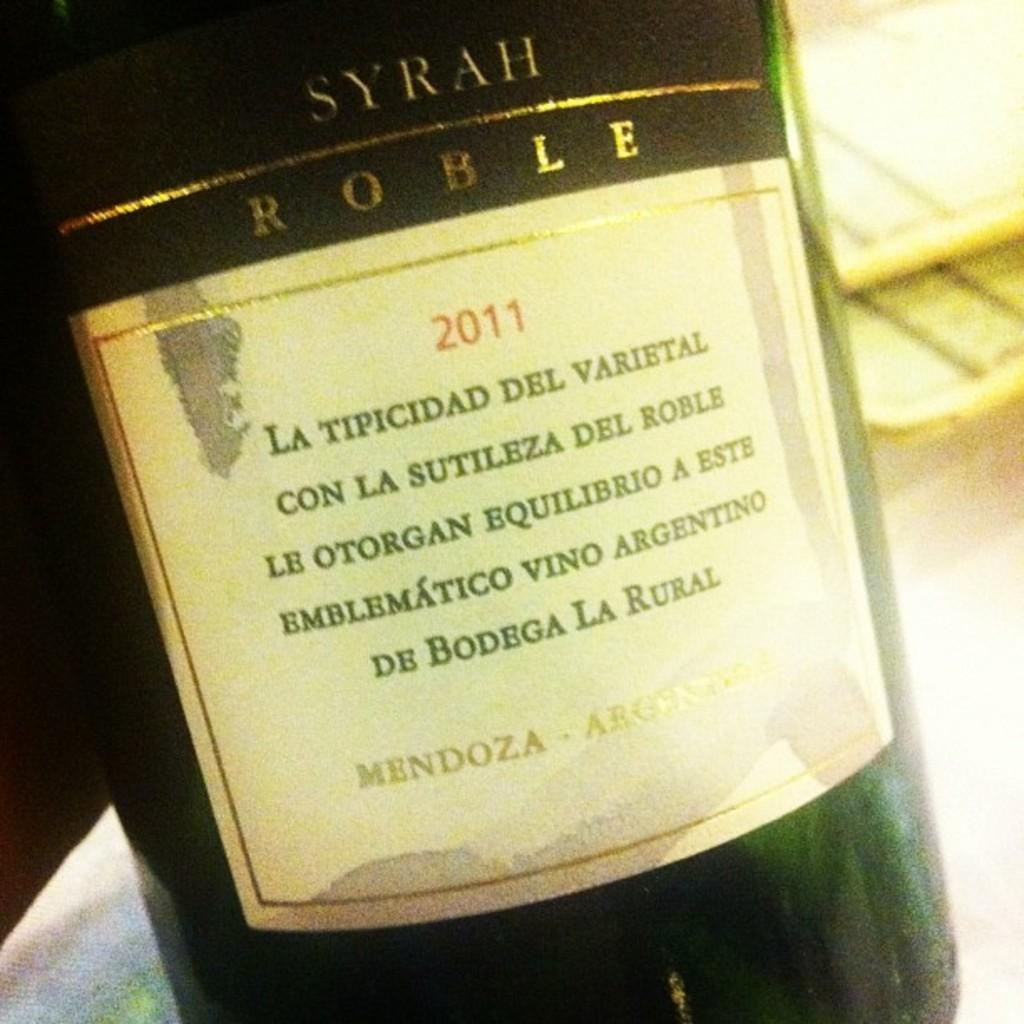<image>
Describe the image concisely. A bottle of wine has a date of 2011 on the label. 